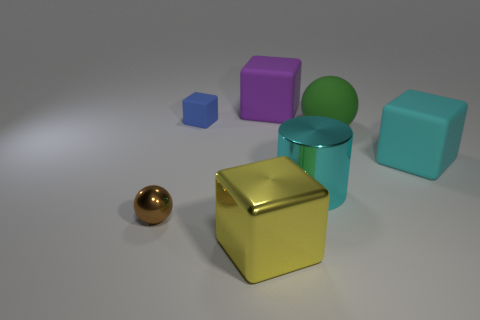Are there any other things that have the same shape as the cyan metallic thing?
Your response must be concise. No. There is a ball that is on the right side of the small metallic ball; are there any rubber things that are on the right side of it?
Your answer should be very brief. Yes. There is a large cube that is on the left side of the cyan matte cube and right of the yellow shiny object; what is its color?
Provide a short and direct response. Purple. The cyan rubber block is what size?
Your answer should be compact. Large. What number of other cyan shiny cylinders are the same size as the cyan cylinder?
Your response must be concise. 0. Is the cube that is left of the yellow block made of the same material as the large cube in front of the large cyan metal thing?
Offer a very short reply. No. What is the material of the cube that is left of the big block in front of the cyan metal thing?
Keep it short and to the point. Rubber. What material is the cube on the right side of the big purple block?
Give a very brief answer. Rubber. What number of yellow objects have the same shape as the large purple thing?
Your answer should be compact. 1. Do the metal cube and the rubber sphere have the same color?
Your response must be concise. No. 